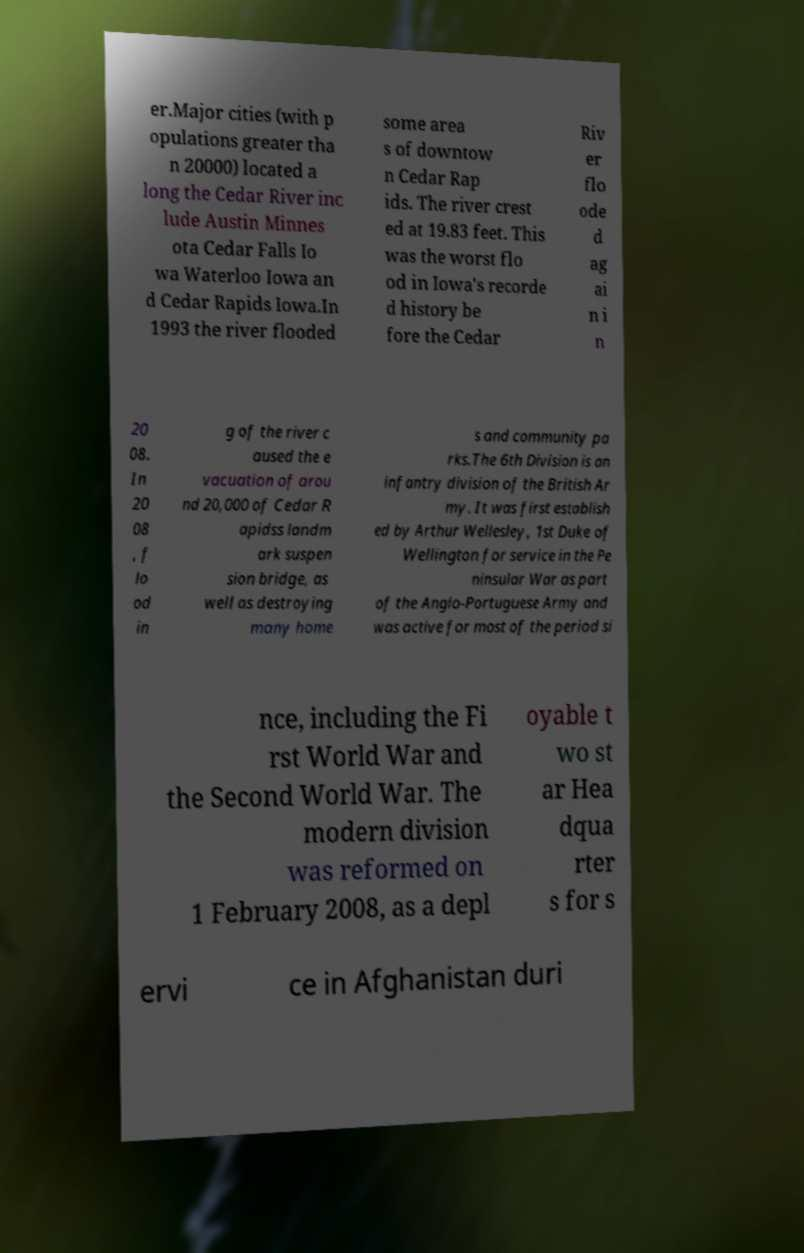For documentation purposes, I need the text within this image transcribed. Could you provide that? er.Major cities (with p opulations greater tha n 20000) located a long the Cedar River inc lude Austin Minnes ota Cedar Falls Io wa Waterloo Iowa an d Cedar Rapids Iowa.In 1993 the river flooded some area s of downtow n Cedar Rap ids. The river crest ed at 19.83 feet. This was the worst flo od in Iowa's recorde d history be fore the Cedar Riv er flo ode d ag ai n i n 20 08. In 20 08 , f lo od in g of the river c aused the e vacuation of arou nd 20,000 of Cedar R apidss landm ark suspen sion bridge, as well as destroying many home s and community pa rks.The 6th Division is an infantry division of the British Ar my. It was first establish ed by Arthur Wellesley, 1st Duke of Wellington for service in the Pe ninsular War as part of the Anglo-Portuguese Army and was active for most of the period si nce, including the Fi rst World War and the Second World War. The modern division was reformed on 1 February 2008, as a depl oyable t wo st ar Hea dqua rter s for s ervi ce in Afghanistan duri 